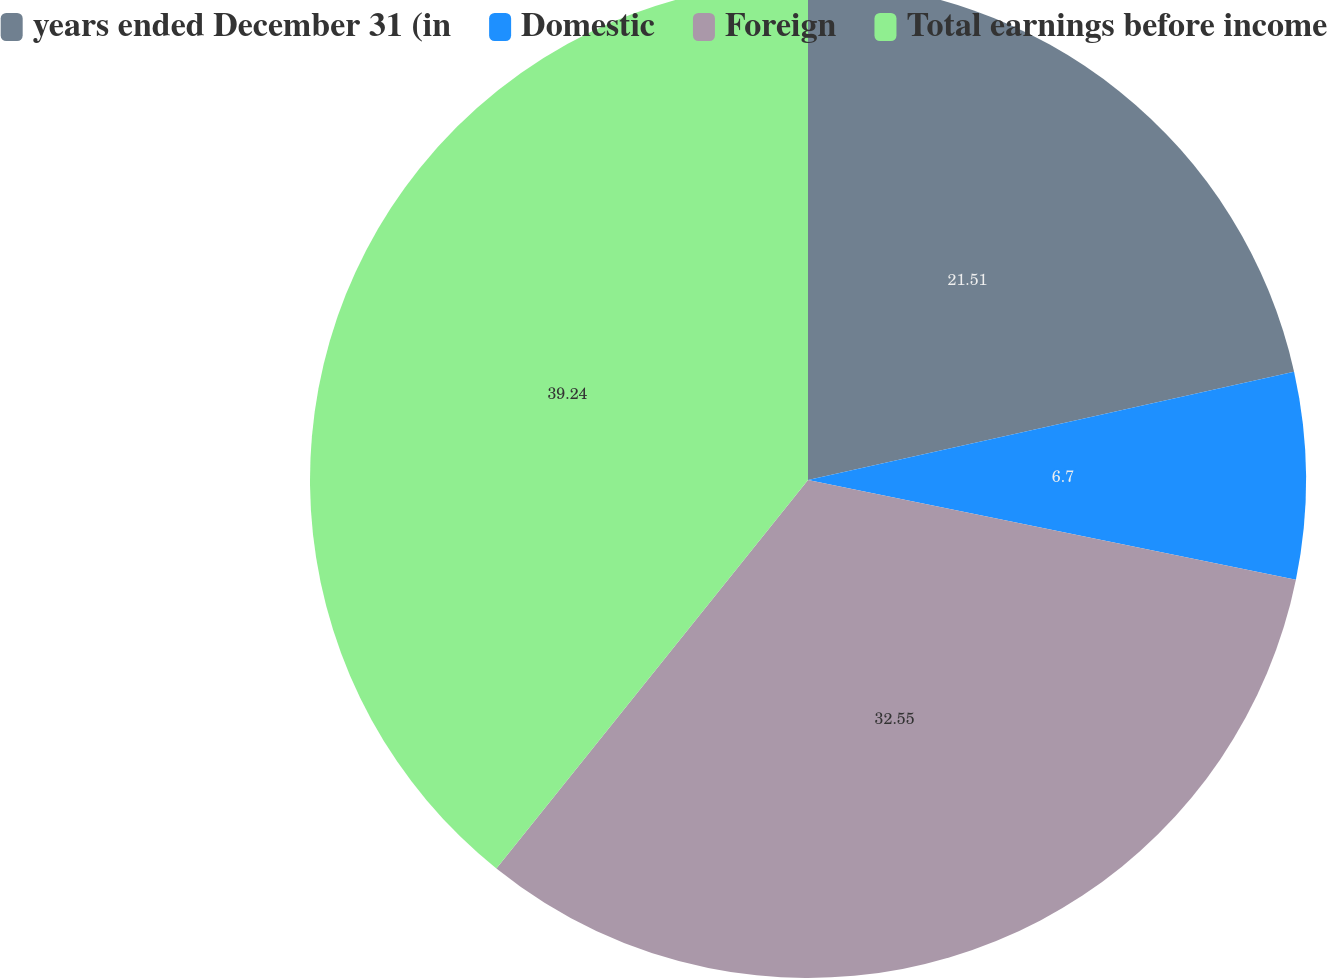Convert chart to OTSL. <chart><loc_0><loc_0><loc_500><loc_500><pie_chart><fcel>years ended December 31 (in<fcel>Domestic<fcel>Foreign<fcel>Total earnings before income<nl><fcel>21.51%<fcel>6.7%<fcel>32.55%<fcel>39.24%<nl></chart> 